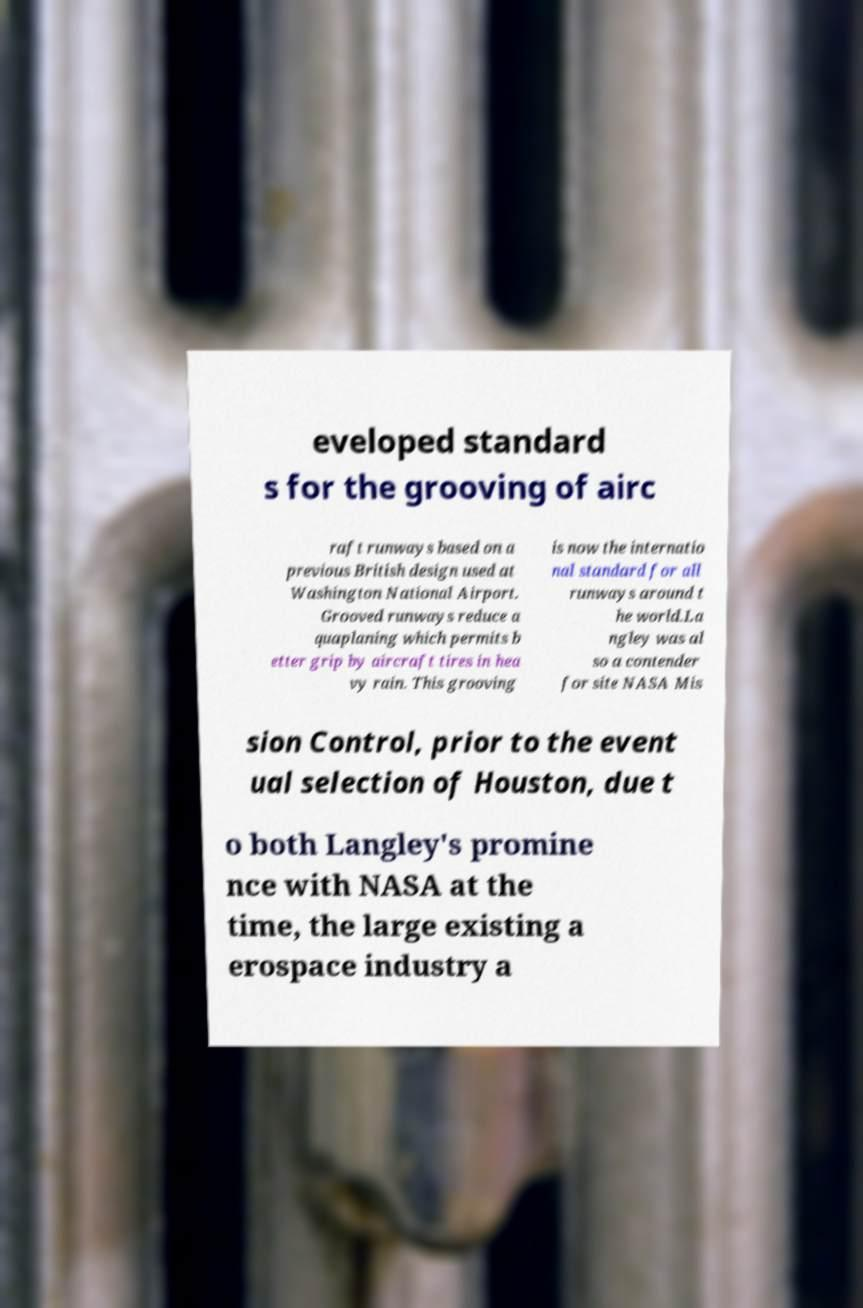Can you accurately transcribe the text from the provided image for me? eveloped standard s for the grooving of airc raft runways based on a previous British design used at Washington National Airport. Grooved runways reduce a quaplaning which permits b etter grip by aircraft tires in hea vy rain. This grooving is now the internatio nal standard for all runways around t he world.La ngley was al so a contender for site NASA Mis sion Control, prior to the event ual selection of Houston, due t o both Langley's promine nce with NASA at the time, the large existing a erospace industry a 